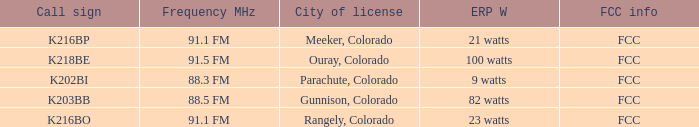Which FCC info has an ERP W of 100 watts? FCC. 